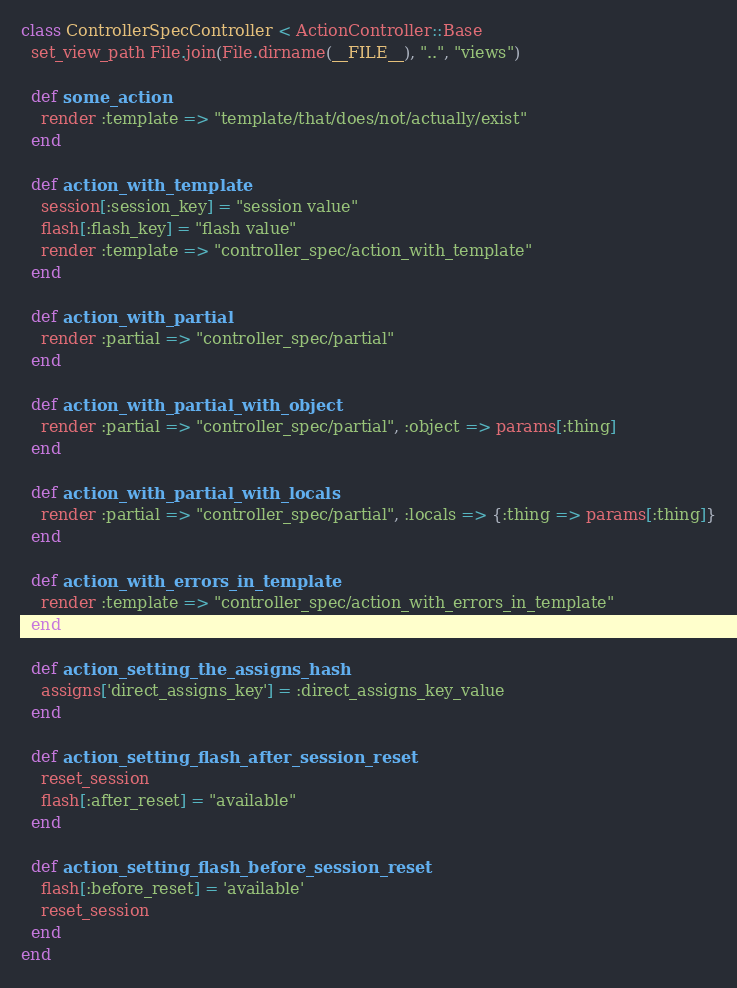Convert code to text. <code><loc_0><loc_0><loc_500><loc_500><_Ruby_>class ControllerSpecController < ActionController::Base
  set_view_path File.join(File.dirname(__FILE__), "..", "views")
  
  def some_action
    render :template => "template/that/does/not/actually/exist"
  end
  
  def action_with_template
    session[:session_key] = "session value"
    flash[:flash_key] = "flash value"
    render :template => "controller_spec/action_with_template"
  end
  
  def action_with_partial
    render :partial => "controller_spec/partial"
  end
  
  def action_with_partial_with_object
    render :partial => "controller_spec/partial", :object => params[:thing]
  end
  
  def action_with_partial_with_locals
    render :partial => "controller_spec/partial", :locals => {:thing => params[:thing]}
  end
  
  def action_with_errors_in_template
    render :template => "controller_spec/action_with_errors_in_template"
  end

  def action_setting_the_assigns_hash
    assigns['direct_assigns_key'] = :direct_assigns_key_value
  end

  def action_setting_flash_after_session_reset
    reset_session
    flash[:after_reset] = "available"
  end
  
  def action_setting_flash_before_session_reset
    flash[:before_reset] = 'available'
    reset_session
  end
end

</code> 